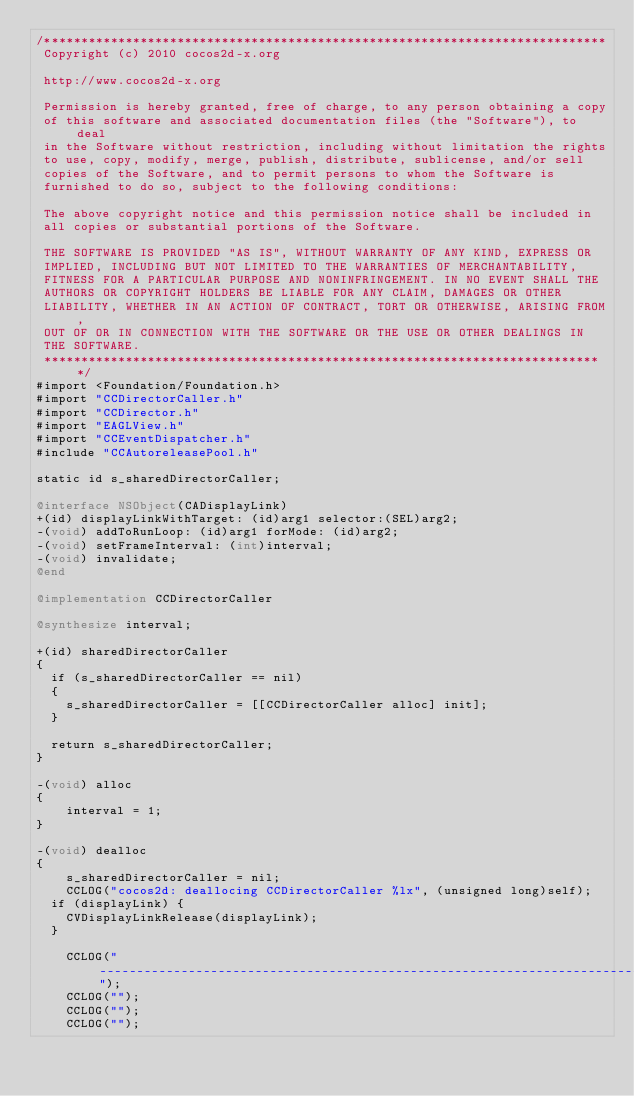Convert code to text. <code><loc_0><loc_0><loc_500><loc_500><_ObjectiveC_>/****************************************************************************
 Copyright (c) 2010 cocos2d-x.org
 
 http://www.cocos2d-x.org
 
 Permission is hereby granted, free of charge, to any person obtaining a copy
 of this software and associated documentation files (the "Software"), to deal
 in the Software without restriction, including without limitation the rights
 to use, copy, modify, merge, publish, distribute, sublicense, and/or sell
 copies of the Software, and to permit persons to whom the Software is
 furnished to do so, subject to the following conditions:
 
 The above copyright notice and this permission notice shall be included in
 all copies or substantial portions of the Software.
 
 THE SOFTWARE IS PROVIDED "AS IS", WITHOUT WARRANTY OF ANY KIND, EXPRESS OR
 IMPLIED, INCLUDING BUT NOT LIMITED TO THE WARRANTIES OF MERCHANTABILITY,
 FITNESS FOR A PARTICULAR PURPOSE AND NONINFRINGEMENT. IN NO EVENT SHALL THE
 AUTHORS OR COPYRIGHT HOLDERS BE LIABLE FOR ANY CLAIM, DAMAGES OR OTHER
 LIABILITY, WHETHER IN AN ACTION OF CONTRACT, TORT OR OTHERWISE, ARISING FROM,
 OUT OF OR IN CONNECTION WITH THE SOFTWARE OR THE USE OR OTHER DEALINGS IN
 THE SOFTWARE.
 ****************************************************************************/
#import <Foundation/Foundation.h>
#import "CCDirectorCaller.h"
#import "CCDirector.h"
#import "EAGLView.h"
#import "CCEventDispatcher.h"
#include "CCAutoreleasePool.h"

static id s_sharedDirectorCaller;

@interface NSObject(CADisplayLink)
+(id) displayLinkWithTarget: (id)arg1 selector:(SEL)arg2;
-(void) addToRunLoop: (id)arg1 forMode: (id)arg2;
-(void) setFrameInterval: (int)interval;
-(void) invalidate;
@end

@implementation CCDirectorCaller

@synthesize interval;

+(id) sharedDirectorCaller
{
	if (s_sharedDirectorCaller == nil)
	{
		s_sharedDirectorCaller = [[CCDirectorCaller alloc] init];
	}
	
	return s_sharedDirectorCaller;
}

-(void) alloc
{
    interval = 1;
}

-(void) dealloc
{
    s_sharedDirectorCaller = nil;
    CCLOG("cocos2d: deallocing CCDirectorCaller %lx", (unsigned long)self);
	if (displayLink) {
		CVDisplayLinkRelease(displayLink);
	}
    
    CCLOG("--------------------------------------------------------------------------------");
    CCLOG("");
    CCLOG("");
    CCLOG("");</code> 